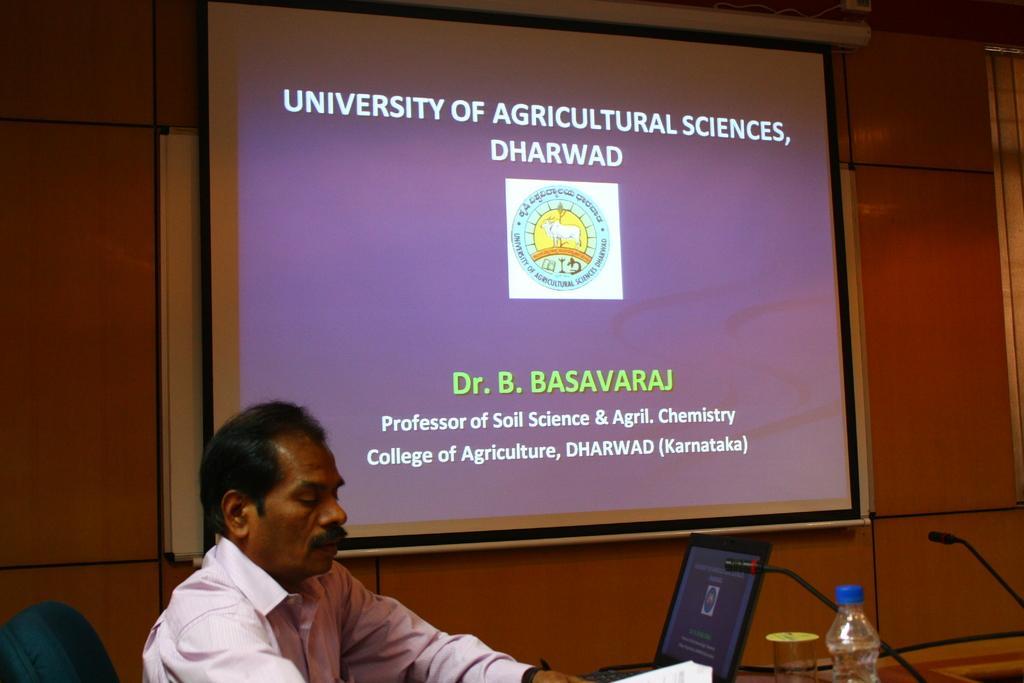<image>
Describe the image concisely. A teacher sitting in front of a screen where a powerpoint titled University of Agricultural Sciences, Dharwad 